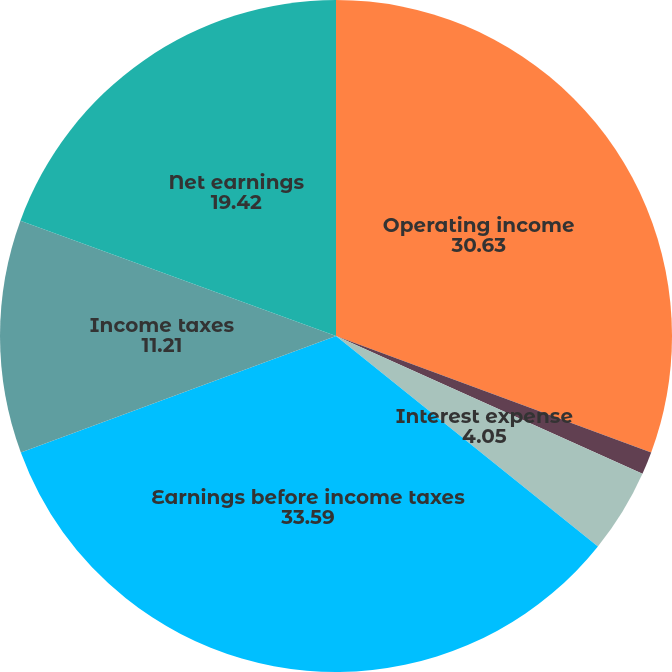<chart> <loc_0><loc_0><loc_500><loc_500><pie_chart><fcel>Operating income<fcel>Interest income and other net<fcel>Interest expense<fcel>Earnings before income taxes<fcel>Income taxes<fcel>Net earnings<nl><fcel>30.63%<fcel>1.09%<fcel>4.05%<fcel>33.59%<fcel>11.21%<fcel>19.42%<nl></chart> 